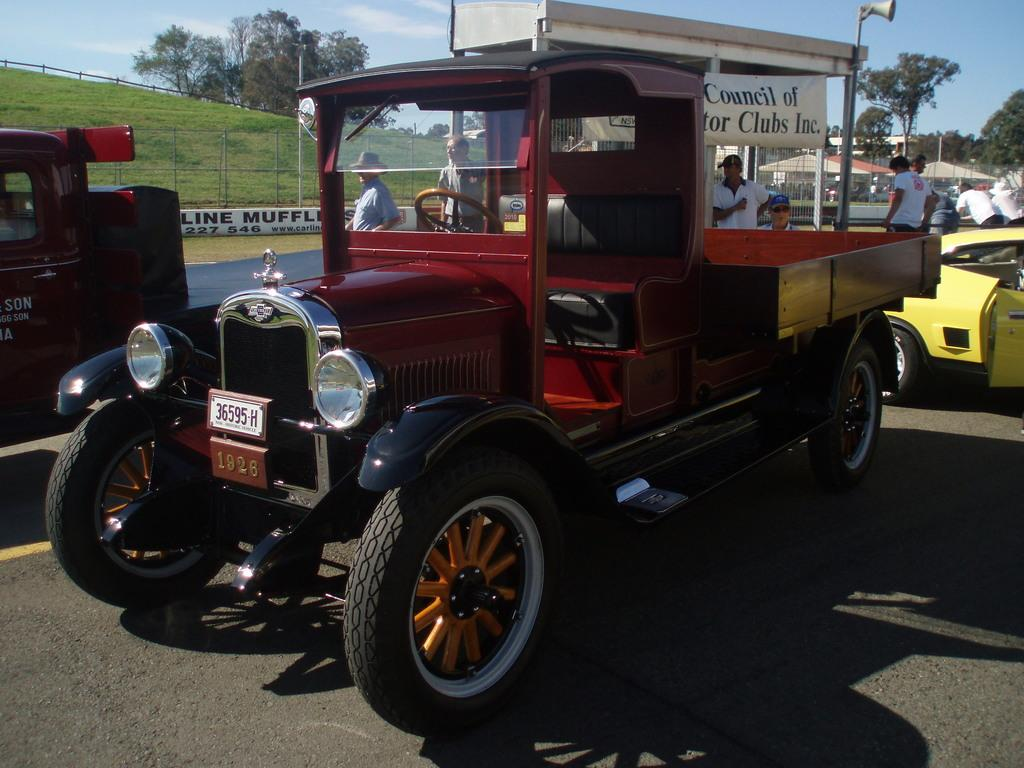What is happening on the road in the image? There are vehicles and people on the road in the image. What can be seen hanging above the road in the image? There are banners in the image. What type of barriers are present along the road in the image? There are fences in the image. What are the tall, thin structures in the image? There are poles in the image. What type of vegetation is present in the image? There are trees and grass in the image. What is visible in the background of the image? The sky is visible in the background of the image. What type of glue is being used to hold the rhythm together in the image? There is no glue or rhythm present in the image; it features vehicles, people, banners, fences, poles, trees, grass, and the sky. What letters are being used to spell out the message on the banners in the image? The banners in the image do not contain any visible letters or messages. 